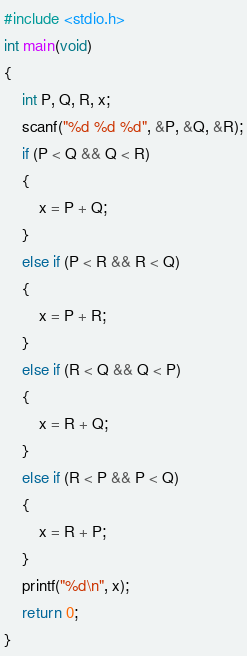<code> <loc_0><loc_0><loc_500><loc_500><_C_>#include <stdio.h>
int main(void)
{
    int P, Q, R, x;
    scanf("%d %d %d", &P, &Q, &R);
    if (P < Q && Q < R)
    {
        x = P + Q;
    }
    else if (P < R && R < Q)
    {
        x = P + R;
    }
    else if (R < Q && Q < P)
    {
        x = R + Q;
    }
    else if (R < P && P < Q)
    {
        x = R + P;
    }
    printf("%d\n", x);
    return 0;
}</code> 